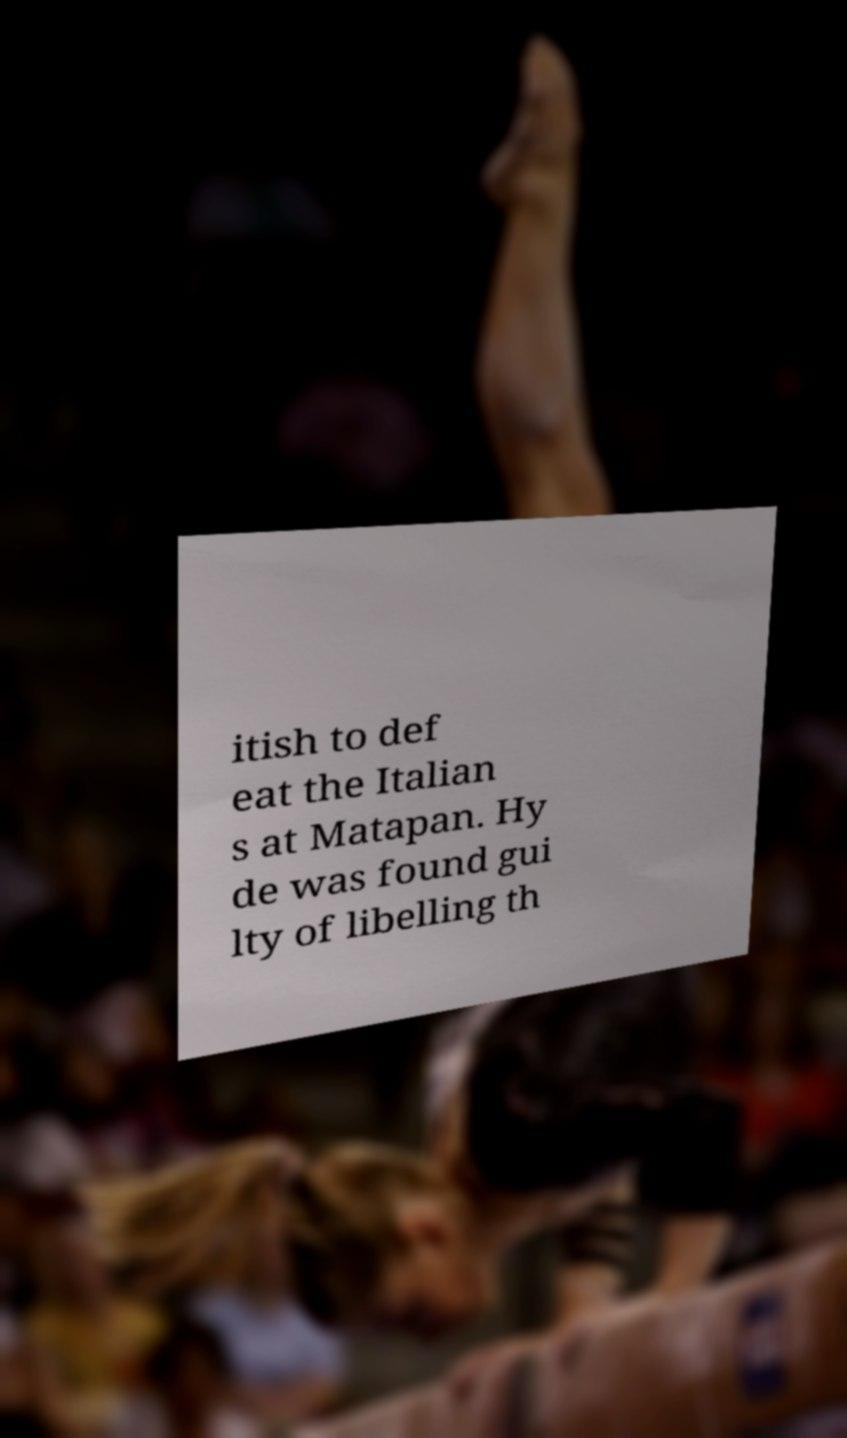Please identify and transcribe the text found in this image. itish to def eat the Italian s at Matapan. Hy de was found gui lty of libelling th 